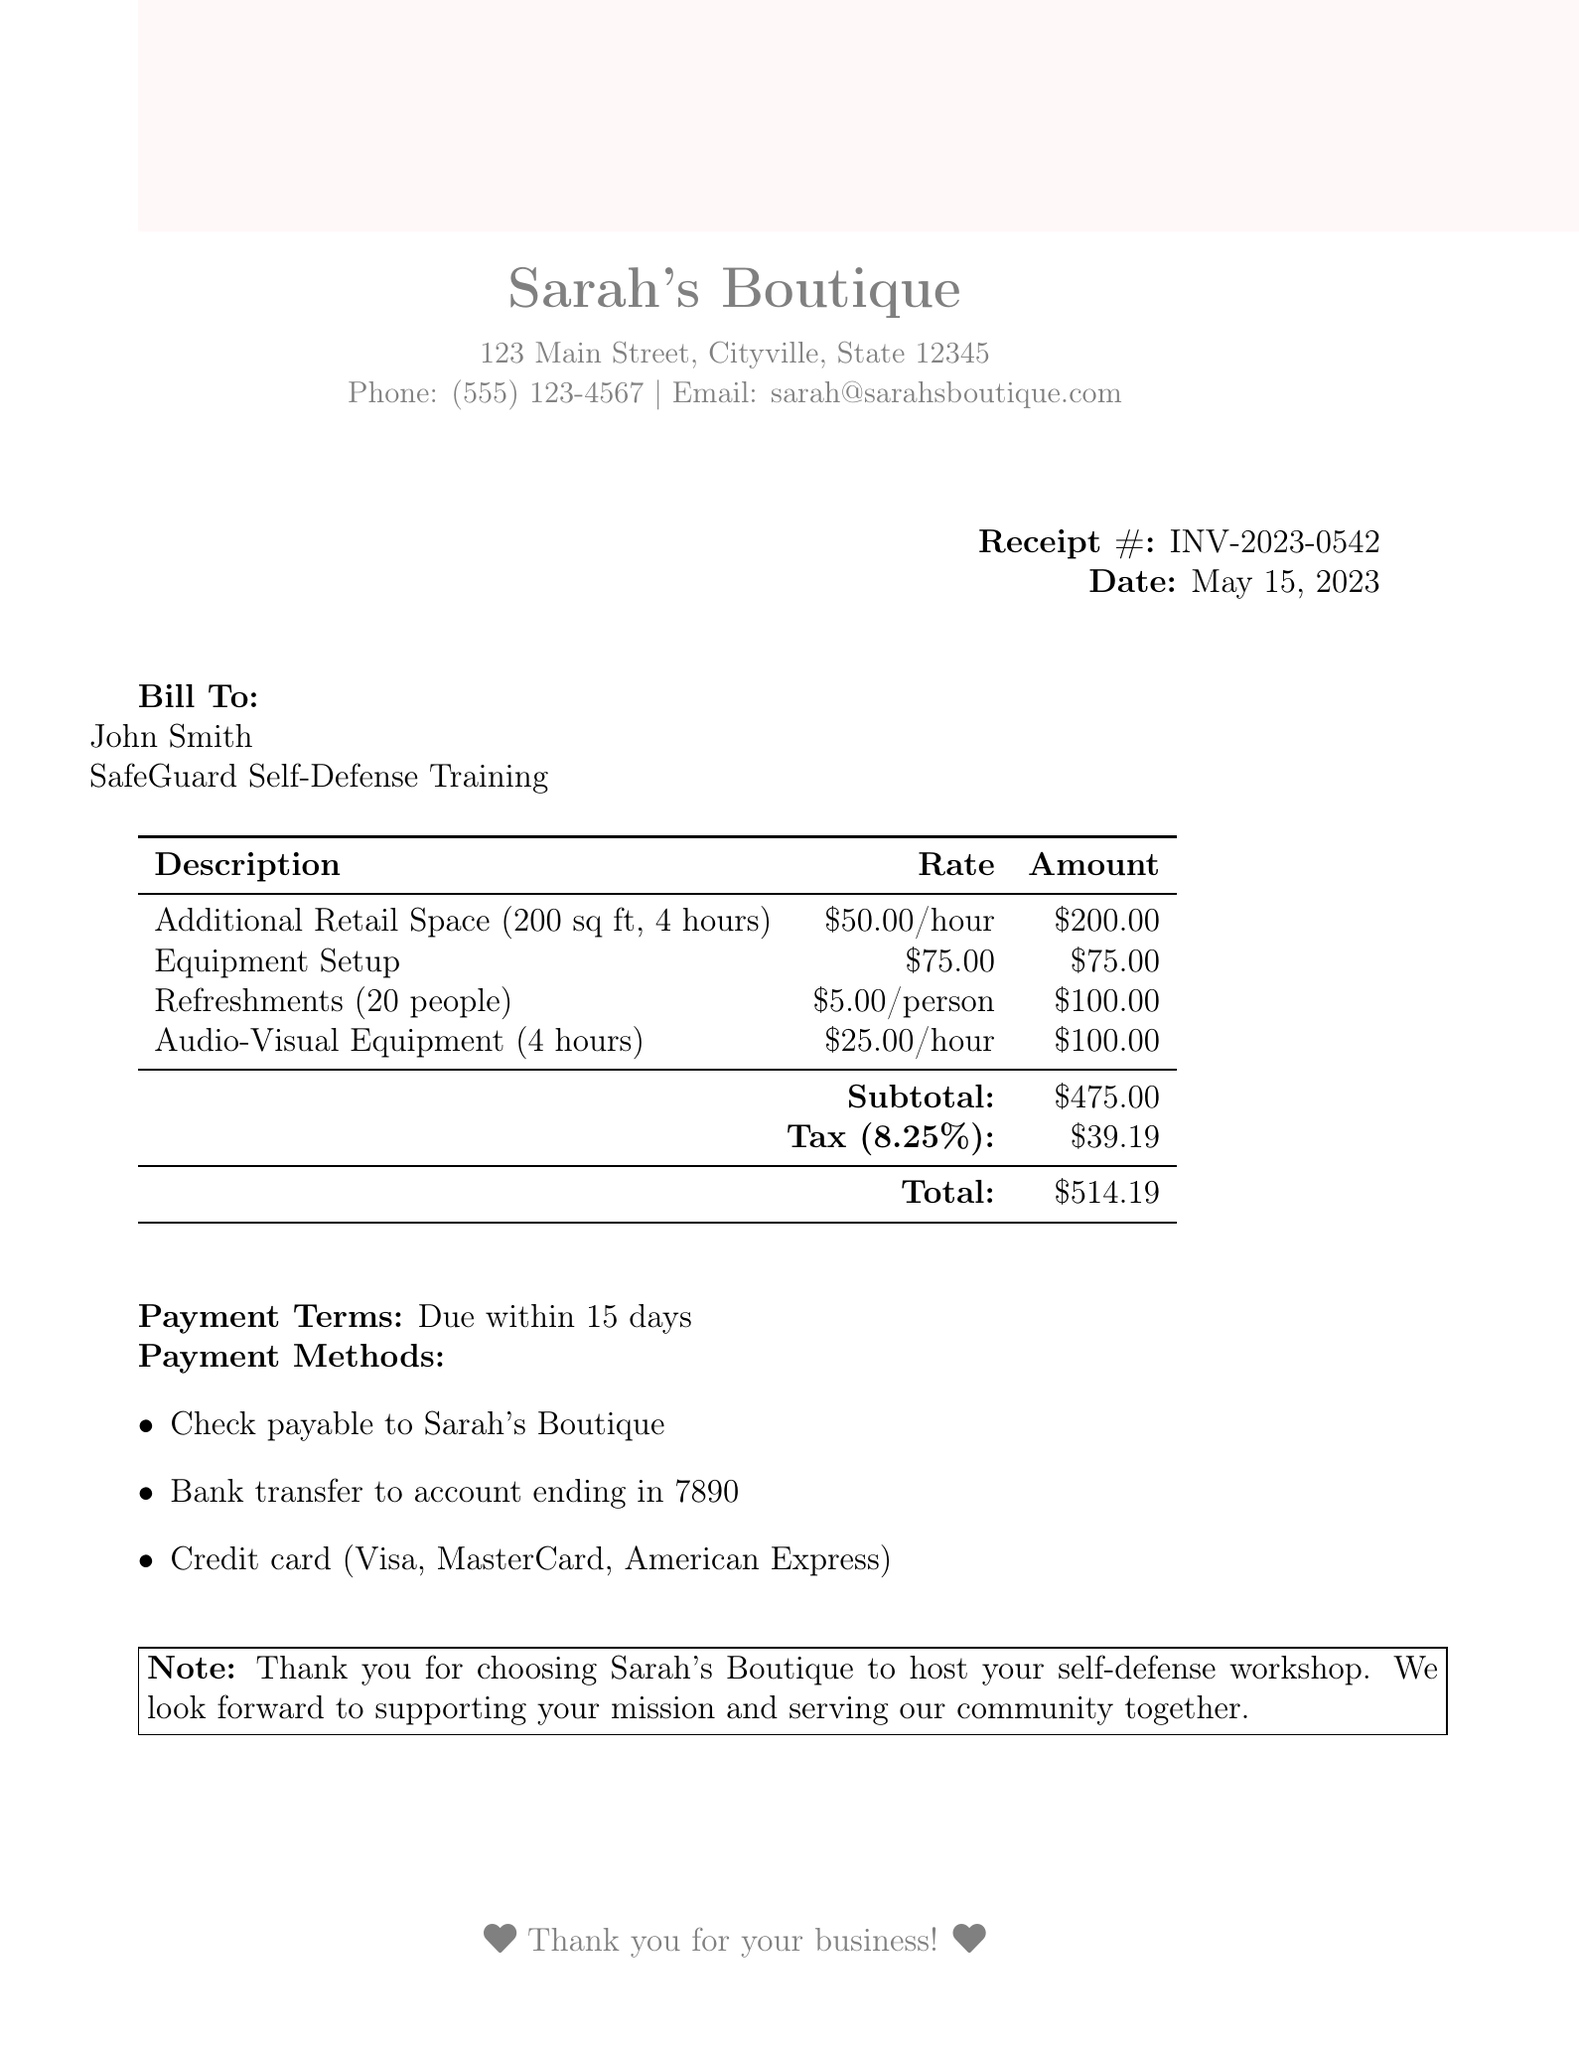What is the receipt number? The receipt number is specified in the document for reference.
Answer: INV-2023-0542 What is the date of the invoice? The date indicates when the transaction took place, which is mentioned in the document.
Answer: May 15, 2023 What is the subtotal amount? The subtotal is the total before tax, calculated from the individual rental and service charges.
Answer: $475.00 Who is the instructor for the workshop? The name of the instructor is mentioned to identify the party responsible for leading the workshop.
Answer: John Smith How much is charged per hour for the additional retail space? This rate is specified in the rental details for clarity on costs associated with space usage.
Answer: $50.00 per hour What is the total amount due after tax? The total reflects the full charge including tax based on the included calculations in the document.
Answer: $514.19 How many people are refreshments provided for? This detail clarifies the quantity of refreshments included in the service offering.
Answer: 20 What is the payment term for this invoice? This term guides when the payment should be made based on the agreement in the document.
Answer: Due within 15 days What type of equipment is rented for the workshop? This item is outlined in the document to specify what additional resources are provided.
Answer: Audio-Visual Equipment 